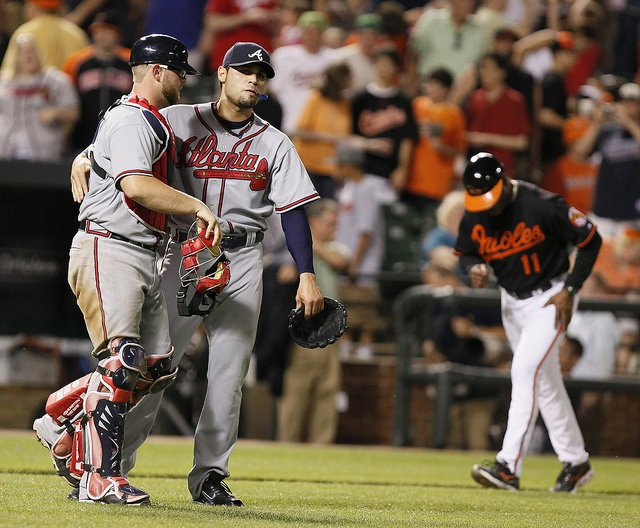Describe the objects in this image and their specific colors. I can see people in maroon, black, darkgray, and gray tones, people in maroon, black, lightgray, gray, and darkgray tones, people in maroon, darkgray, gray, black, and lightgray tones, people in maroon, black, lightgray, and darkgray tones, and people in maroon and gray tones in this image. 